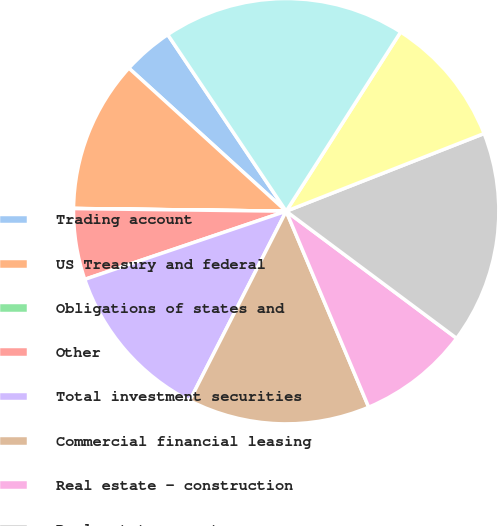Convert chart to OTSL. <chart><loc_0><loc_0><loc_500><loc_500><pie_chart><fcel>Trading account<fcel>US Treasury and federal<fcel>Obligations of states and<fcel>Other<fcel>Total investment securities<fcel>Commercial financial leasing<fcel>Real estate - construction<fcel>Real estate - mortgage<fcel>Consumer<fcel>Total loans and leases<nl><fcel>3.85%<fcel>11.54%<fcel>0.01%<fcel>5.39%<fcel>12.31%<fcel>13.84%<fcel>8.46%<fcel>16.15%<fcel>10.0%<fcel>18.45%<nl></chart> 